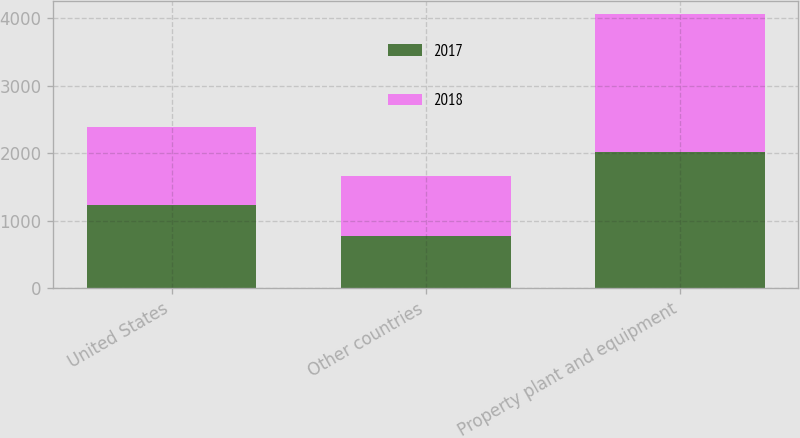Convert chart to OTSL. <chart><loc_0><loc_0><loc_500><loc_500><stacked_bar_chart><ecel><fcel>United States<fcel>Other countries<fcel>Property plant and equipment<nl><fcel>2017<fcel>1235.1<fcel>780.3<fcel>2015.4<nl><fcel>2018<fcel>1151.6<fcel>887<fcel>2038.6<nl></chart> 